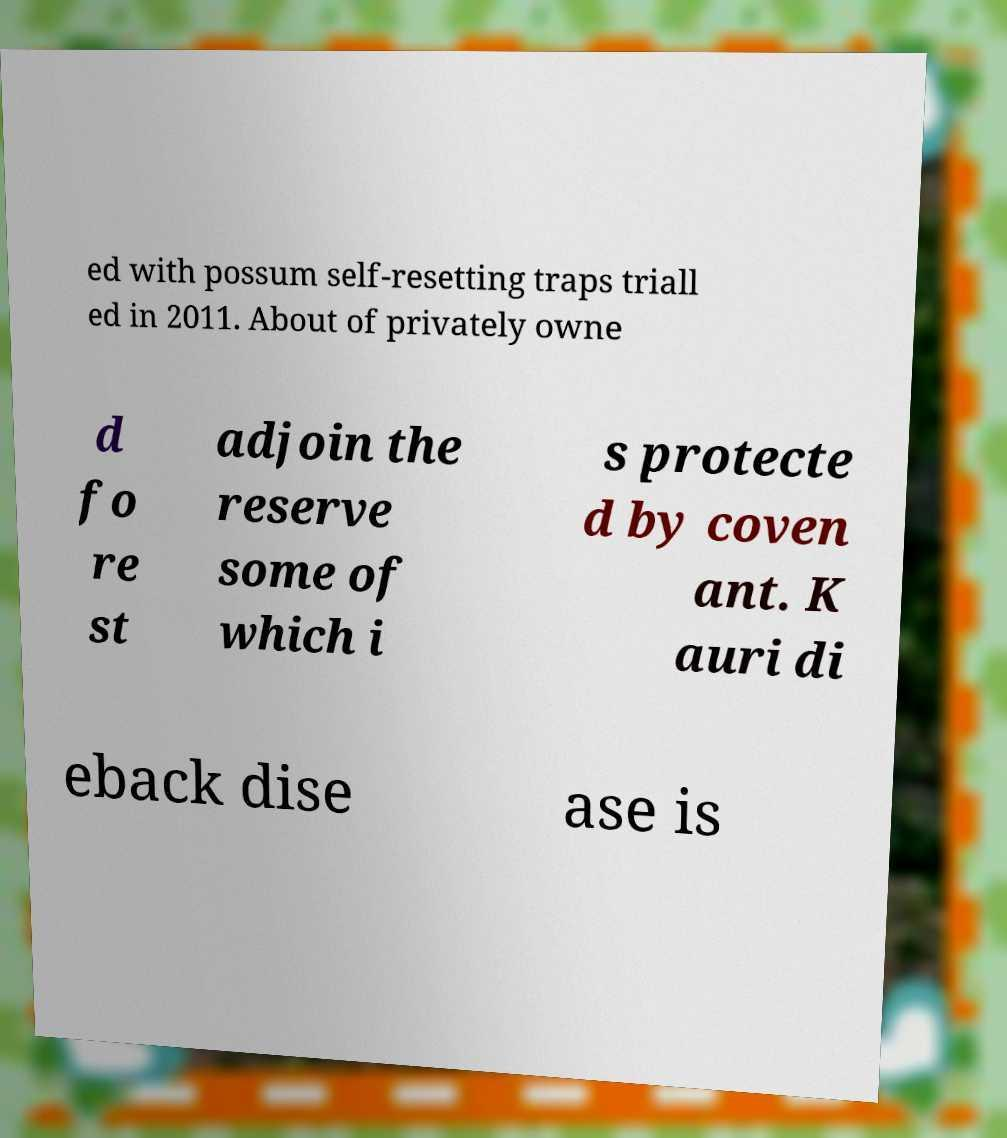I need the written content from this picture converted into text. Can you do that? ed with possum self-resetting traps triall ed in 2011. About of privately owne d fo re st adjoin the reserve some of which i s protecte d by coven ant. K auri di eback dise ase is 